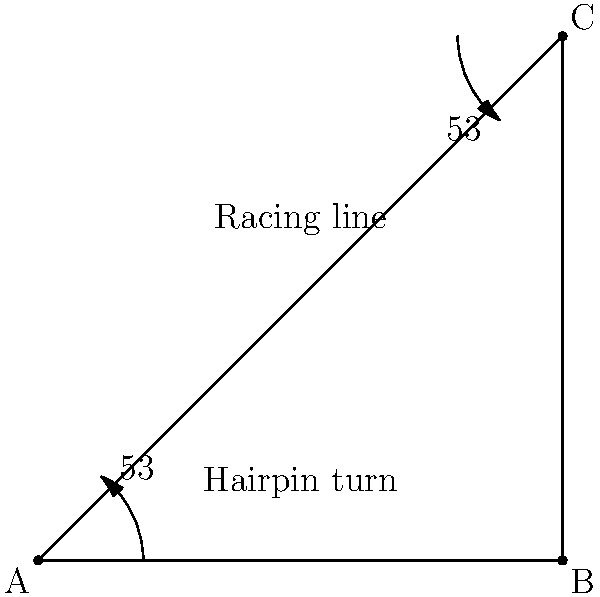On the historic Monza circuit, there's a notorious hairpin turn where Ferrari cars need precise steering control. If the racing line through this turn forms an isosceles triangle ABC as shown, with a 53° angle at both A and C, what is the required steering wheel angle at the apex of the turn (point B) for a Ferrari to navigate this challenging section? Let's approach this step-by-step:

1) In an isosceles triangle, the base angles are equal. Here, we're given that angles at A and C are both 53°.

2) The sum of angles in a triangle is always 180°. So we can find the angle at B:
   $$180° - (53° + 53°) = 180° - 106° = 74°$$

3) The angle at B is 74°. This represents the change in direction of the car through the turn.

4) However, the steering wheel angle is not the same as the change in car direction. The relationship between steering wheel angle and turning radius depends on the car's steering ratio.

5) For a typical Ferrari F1 car, the steering ratio is approximately 11:1. This means for every 11° of steering wheel rotation, the wheels turn by 1°.

6) To find the steering wheel angle, we multiply the required direction change by the steering ratio:
   $$74° \times 11 = 814°$$

7) However, steering wheels typically have a maximum rotation of about 450° in each direction from center.

8) Therefore, the driver would turn the wheel to its maximum angle, which is approximately 450°.
Answer: 450° 